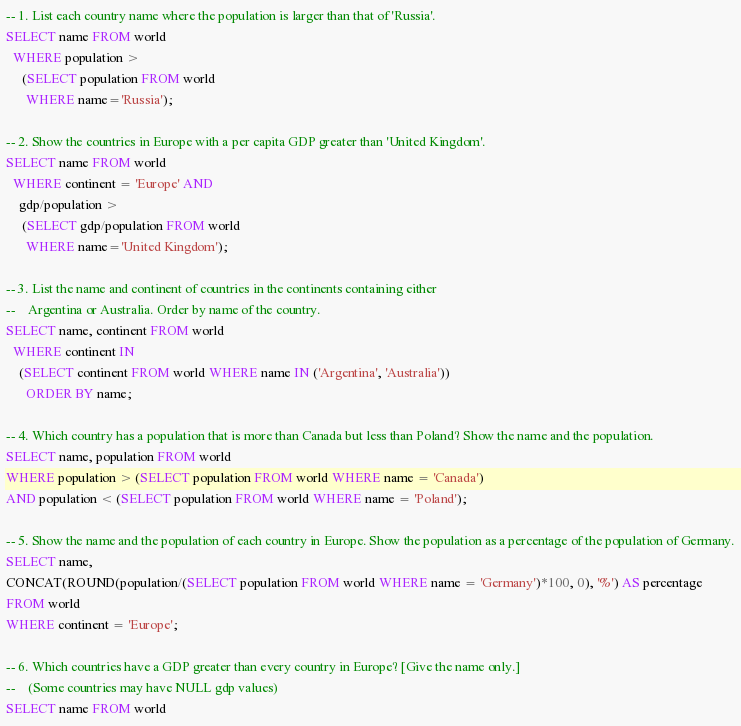<code> <loc_0><loc_0><loc_500><loc_500><_SQL_>-- 1. List each country name where the population is larger than that of 'Russia'.
SELECT name FROM world
  WHERE population >
     (SELECT population FROM world
      WHERE name='Russia');

-- 2. Show the countries in Europe with a per capita GDP greater than 'United Kingdom'.
SELECT name FROM world
  WHERE continent = 'Europe' AND
    gdp/population >
     (SELECT gdp/population FROM world
      WHERE name='United Kingdom');

-- 3. List the name and continent of countries in the continents containing either
--    Argentina or Australia. Order by name of the country.
SELECT name, continent FROM world
  WHERE continent IN
    (SELECT continent FROM world WHERE name IN ('Argentina', 'Australia'))
      ORDER BY name;

-- 4. Which country has a population that is more than Canada but less than Poland? Show the name and the population.
SELECT name, population FROM world
WHERE population > (SELECT population FROM world WHERE name = 'Canada')
AND population < (SELECT population FROM world WHERE name = 'Poland');

-- 5. Show the name and the population of each country in Europe. Show the population as a percentage of the population of Germany.
SELECT name,
CONCAT(ROUND(population/(SELECT population FROM world WHERE name = 'Germany')*100, 0), '%') AS percentage
FROM world
WHERE continent = 'Europe';

-- 6. Which countries have a GDP greater than every country in Europe? [Give the name only.]
--    (Some countries may have NULL gdp values)
SELECT name FROM world</code> 